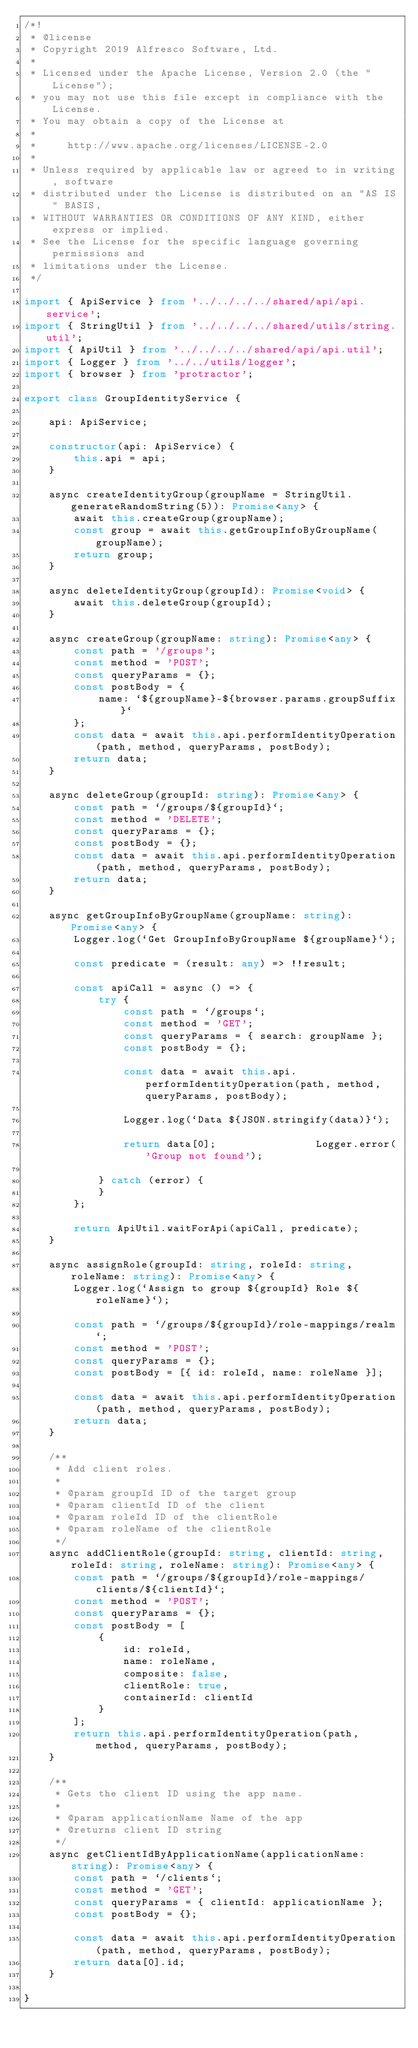<code> <loc_0><loc_0><loc_500><loc_500><_TypeScript_>/*!
 * @license
 * Copyright 2019 Alfresco Software, Ltd.
 *
 * Licensed under the Apache License, Version 2.0 (the "License");
 * you may not use this file except in compliance with the License.
 * You may obtain a copy of the License at
 *
 *     http://www.apache.org/licenses/LICENSE-2.0
 *
 * Unless required by applicable law or agreed to in writing, software
 * distributed under the License is distributed on an "AS IS" BASIS,
 * WITHOUT WARRANTIES OR CONDITIONS OF ANY KIND, either express or implied.
 * See the License for the specific language governing permissions and
 * limitations under the License.
 */

import { ApiService } from '../../../../shared/api/api.service';
import { StringUtil } from '../../../../shared/utils/string.util';
import { ApiUtil } from '../../../../shared/api/api.util';
import { Logger } from '../../utils/logger';
import { browser } from 'protractor';

export class GroupIdentityService {

    api: ApiService;

    constructor(api: ApiService) {
        this.api = api;
    }

    async createIdentityGroup(groupName = StringUtil.generateRandomString(5)): Promise<any> {
        await this.createGroup(groupName);
        const group = await this.getGroupInfoByGroupName(groupName);
        return group;
    }

    async deleteIdentityGroup(groupId): Promise<void> {
        await this.deleteGroup(groupId);
    }

    async createGroup(groupName: string): Promise<any> {
        const path = '/groups';
        const method = 'POST';
        const queryParams = {};
        const postBody = {
            name: `${groupName}-${browser.params.groupSuffix}`
        };
        const data = await this.api.performIdentityOperation(path, method, queryParams, postBody);
        return data;
    }

    async deleteGroup(groupId: string): Promise<any> {
        const path = `/groups/${groupId}`;
        const method = 'DELETE';
        const queryParams = {};
        const postBody = {};
        const data = await this.api.performIdentityOperation(path, method, queryParams, postBody);
        return data;
    }

    async getGroupInfoByGroupName(groupName: string): Promise<any> {
        Logger.log(`Get GroupInfoByGroupName ${groupName}`);

        const predicate = (result: any) => !!result;

        const apiCall = async () => {
            try {
                const path = `/groups`;
                const method = 'GET';
                const queryParams = { search: groupName };
                const postBody = {};

                const data = await this.api.performIdentityOperation(path, method, queryParams, postBody);

                Logger.log(`Data ${JSON.stringify(data)}`);

                return data[0];                Logger.error('Group not found');

            } catch (error) {
            }
        };

        return ApiUtil.waitForApi(apiCall, predicate);
    }

    async assignRole(groupId: string, roleId: string, roleName: string): Promise<any> {
        Logger.log(`Assign to group ${groupId} Role ${roleName}`);

        const path = `/groups/${groupId}/role-mappings/realm`;
        const method = 'POST';
        const queryParams = {};
        const postBody = [{ id: roleId, name: roleName }];

        const data = await this.api.performIdentityOperation(path, method, queryParams, postBody);
        return data;
    }

    /**
     * Add client roles.
     *
     * @param groupId ID of the target group
     * @param clientId ID of the client
     * @param roleId ID of the clientRole
     * @param roleName of the clientRole
     */
    async addClientRole(groupId: string, clientId: string, roleId: string, roleName: string): Promise<any> {
        const path = `/groups/${groupId}/role-mappings/clients/${clientId}`;
        const method = 'POST';
        const queryParams = {};
        const postBody = [
            {
                id: roleId,
                name: roleName,
                composite: false,
                clientRole: true,
                containerId: clientId
            }
        ];
        return this.api.performIdentityOperation(path, method, queryParams, postBody);
    }

    /**
     * Gets the client ID using the app name.
     *
     * @param applicationName Name of the app
     * @returns client ID string
     */
    async getClientIdByApplicationName(applicationName: string): Promise<any> {
        const path = `/clients`;
        const method = 'GET';
        const queryParams = { clientId: applicationName };
        const postBody = {};

        const data = await this.api.performIdentityOperation(path, method, queryParams, postBody);
        return data[0].id;
    }

}
</code> 